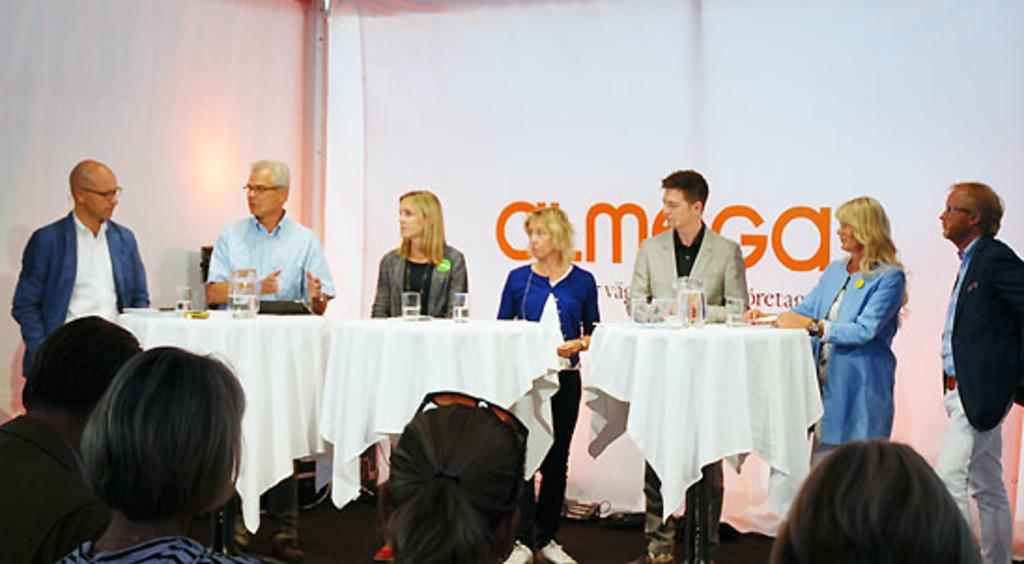How many people are in the image? There are multiple people in the image. What are the majority of the people doing in the image? Most of the people are standing. What objects are in front of the people? There are tables in front of the people. What can be found on the tables? There are glasses and a jar on the tables. How does the dog feel about the people in the image? There is no dog present in the image, so it is not possible to determine how a dog might feel about the people. 